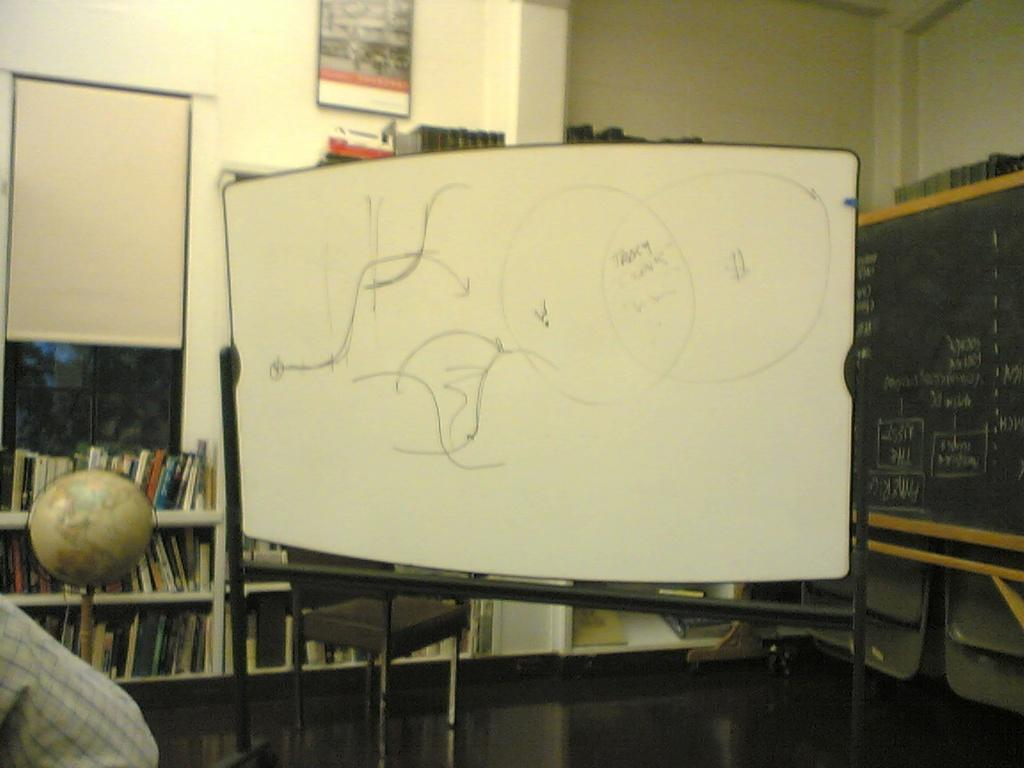What is the main object in the middle of the image? There is a whiteboard in the middle of the image. What can be seen in the background of the image? In the background of the image, there are windows, a globe, books arranged in rows, a blackboard, walls, and a wall hanging. Can you describe the windows in the background? The windows are visible in the background of the image. What type of object is present on the wall in the background? There is a wall hanging in the background of the image. What type of linen is draped over the blackboard in the image? There is no linen draped over the blackboard in the image. How does the lead affect the appearance of the whiteboard in the image? There is no mention of lead in the image, and it does not affect the appearance of the whiteboard. 